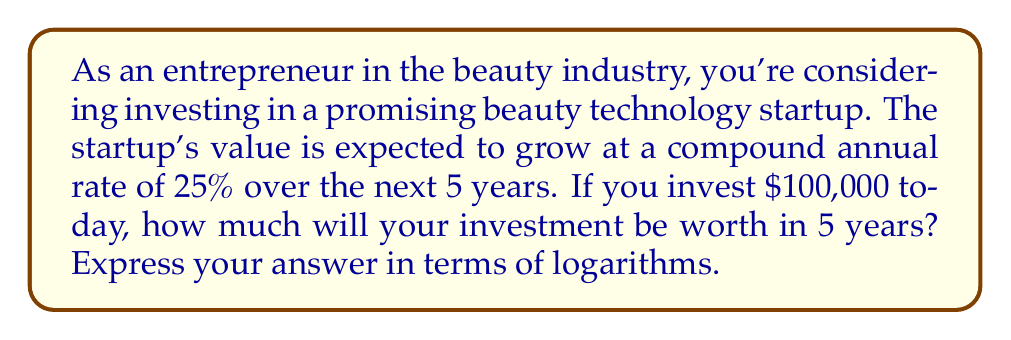What is the answer to this math problem? Let's approach this step-by-step using the compound interest formula and logarithms:

1) The compound interest formula is:
   $A = P(1 + r)^t$
   Where:
   $A$ = Final amount
   $P$ = Principal (initial investment)
   $r$ = Annual interest rate (as a decimal)
   $t$ = Time in years

2) We have:
   $P = 100,000$
   $r = 0.25$ (25% expressed as a decimal)
   $t = 5$ years

3) Plugging these into our formula:
   $A = 100,000(1 + 0.25)^5$

4) To solve this using logarithms, we can take the natural log of both sides:
   $\ln(A) = \ln(100,000(1.25)^5)$

5) Using the properties of logarithms:
   $\ln(A) = \ln(100,000) + 5\ln(1.25)$

6) Now we can calculate:
   $\ln(A) = 11.51293 + 5(0.22314)$
   $\ln(A) = 11.51293 + 1.11570$
   $\ln(A) = 12.62863$

7) To get $A$, we need to apply the exponential function to both sides:
   $A = e^{12.62863}$

8) This gives us our final answer:
   $A \approx 305,175.78$
Answer: The investment will be worth approximately $e^{12.62863} \approx 305,175.78$ in 5 years. 